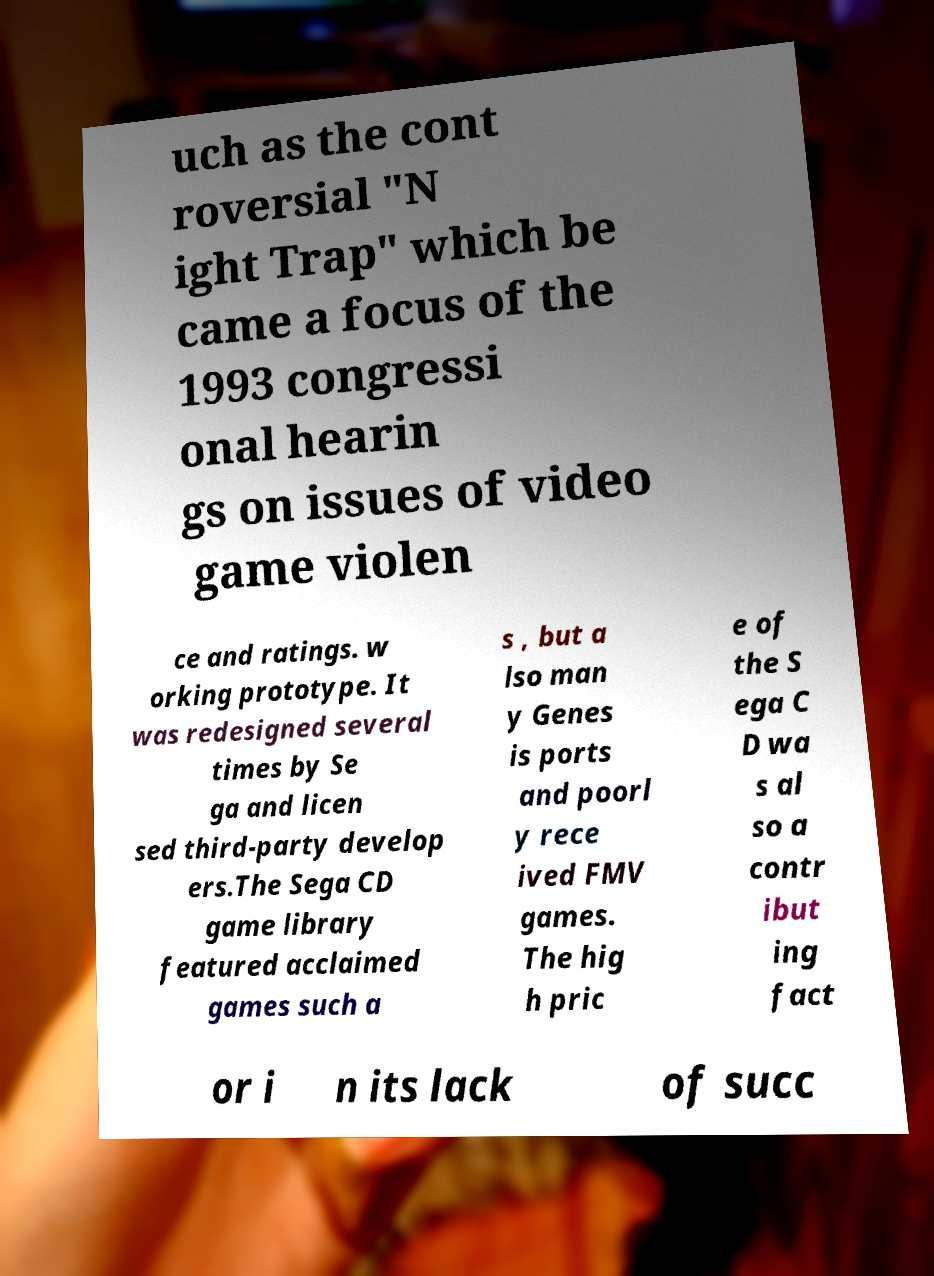Can you read and provide the text displayed in the image?This photo seems to have some interesting text. Can you extract and type it out for me? uch as the cont roversial "N ight Trap" which be came a focus of the 1993 congressi onal hearin gs on issues of video game violen ce and ratings. w orking prototype. It was redesigned several times by Se ga and licen sed third-party develop ers.The Sega CD game library featured acclaimed games such a s , but a lso man y Genes is ports and poorl y rece ived FMV games. The hig h pric e of the S ega C D wa s al so a contr ibut ing fact or i n its lack of succ 